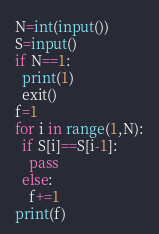Convert code to text. <code><loc_0><loc_0><loc_500><loc_500><_Python_>N=int(input())
S=input()
if N==1:
  print(1)
  exit()
f=1
for i in range(1,N):
  if S[i]==S[i-1]:
    pass
  else:
    f+=1
print(f)</code> 